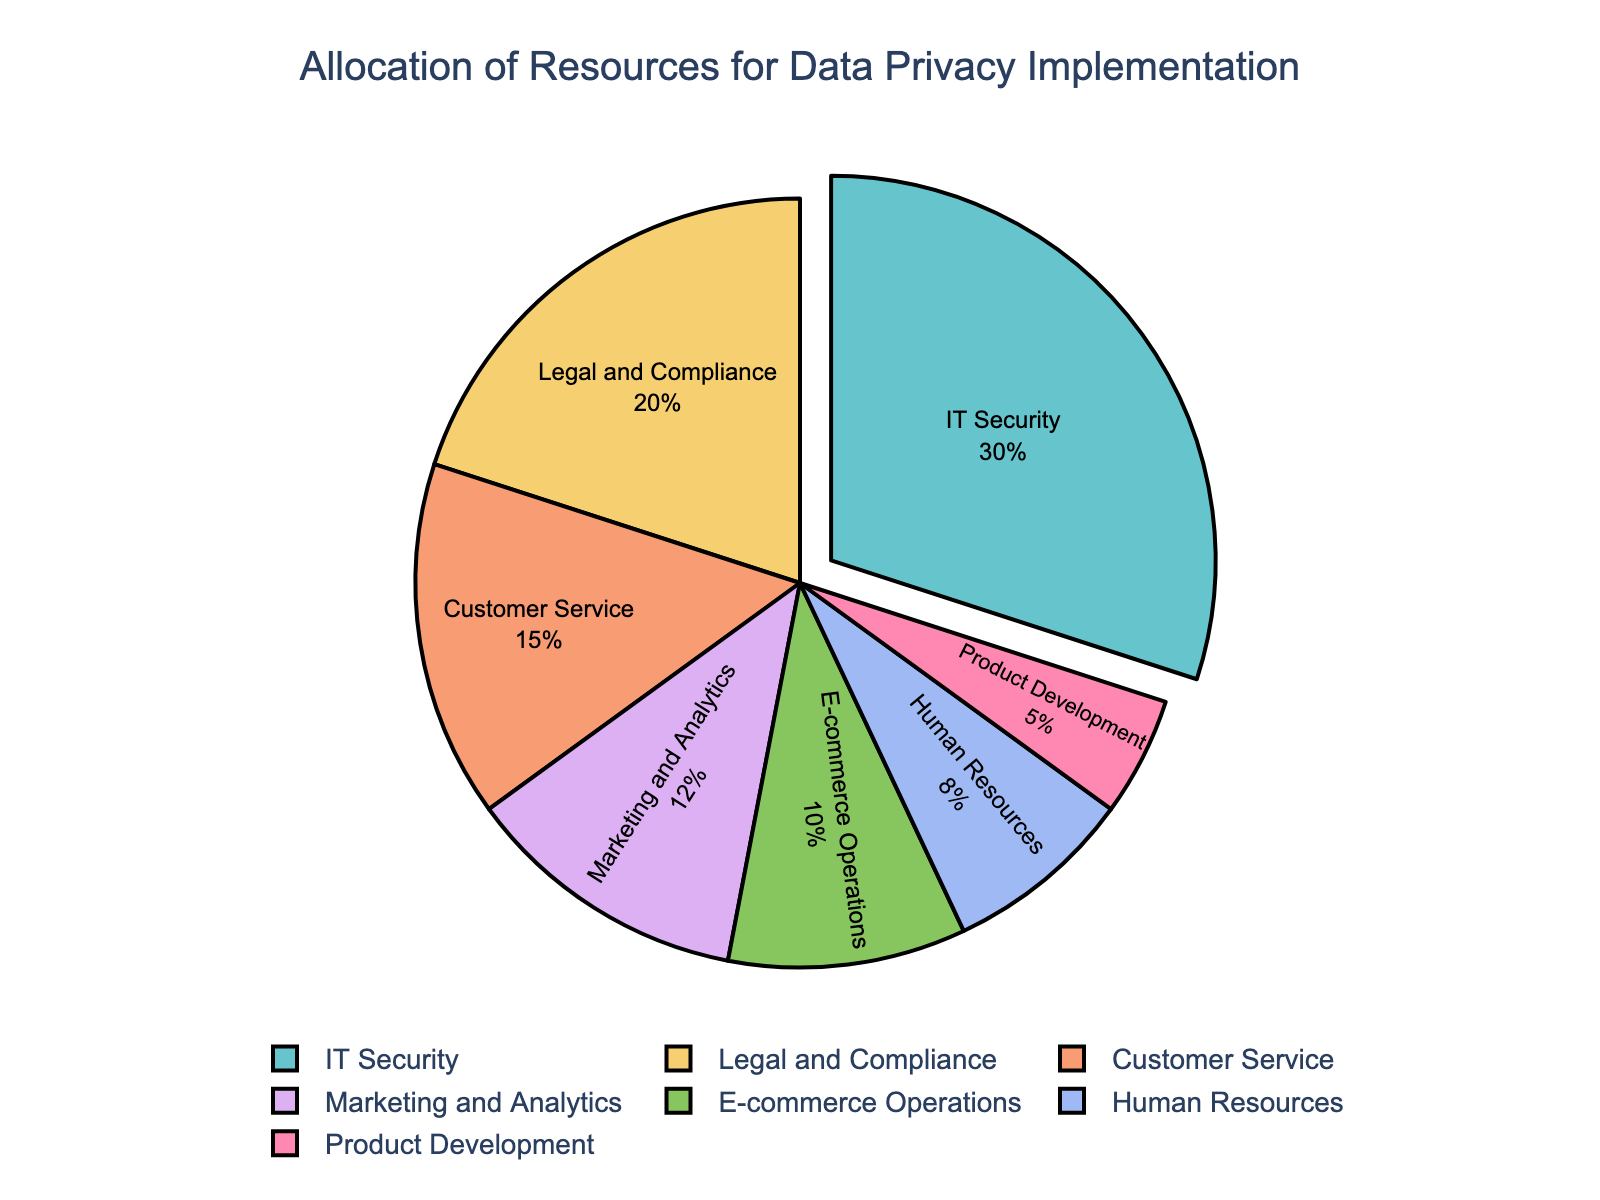what percentage of the budget is allocated to IT Security? According to the pie chart, IT Security is allocated 30% of the budget.
Answer: 30% Which department receives the lowest budget allocation, and what is its percentage? The department with the lowest budget allocation is Product Development, which gets 5% of the budget.
Answer: Product Development, 5% How does the budget for Customer Service compare to that of Marketing and Analytics? The budget allocation for Customer Service is 15%, which is higher than the 12% allocated to Marketing and Analytics.
Answer: Customer Service has a 3% higher allocation than Marketing and Analytics What is the total budget allocation for departments related to customer interaction (Customer Service and E-commerce Operations)? Add the percentages for Customer Service and E-commerce Operations: 15% + 10% = 25%.
Answer: 25% Is the budget allocated to IT Security greater than the combined budget for Human Resources and Product Development? The budget for IT Security is 30%. The combined budget for Human Resources and Product Development is 8% + 5% = 13%. Since 30% is greater than 13%, IT Security has a greater allocation.
Answer: Yes Which department receives more funding: Legal and Compliance or Marketing and Analytics, and by how much? The Legal and Compliance department receives 20% of the budget, while Marketing and Analytics gets 12%. The difference is 20% - 12% = 8%.
Answer: Legal and Compliance by 8% What is the sum of the budget allocations of all departments with allocations less than 10%? The relevant departments are E-commerce Operations (10%), Human Resources (8%), and Product Development (5%). Sum: 10% + 8% + 5% = 23%.
Answer: 23% How does the budget allocated to IT Security compare visually to other departments? Visually, IT Security occupies the largest space in the pie chart and is the only segment pulled out slightly, emphasizing its higher allocation.
Answer: Largest and pulled out What's the difference in the budget allocation between Legal and Compliance and E-commerce Operations? Legal and Compliance has 20%, E-commerce Operations has 10%. The difference is 20% - 10% = 10%.
Answer: 10% Which departments are allocated a combined budget equal to IT Security's budget? IT Security is allocated 30%. The combined budget of Legal and Compliance (20%) and Product Development (5%) is 20% + 5% = 25%, and adding Human Resources (8%) to E-commerce Operations (10%) amounts to 18%. Thus, it's Legal and Compliance plus Customer Service (20% + 15%) that gives us 30%.
Answer: Legal and Compliance and Customer Service 